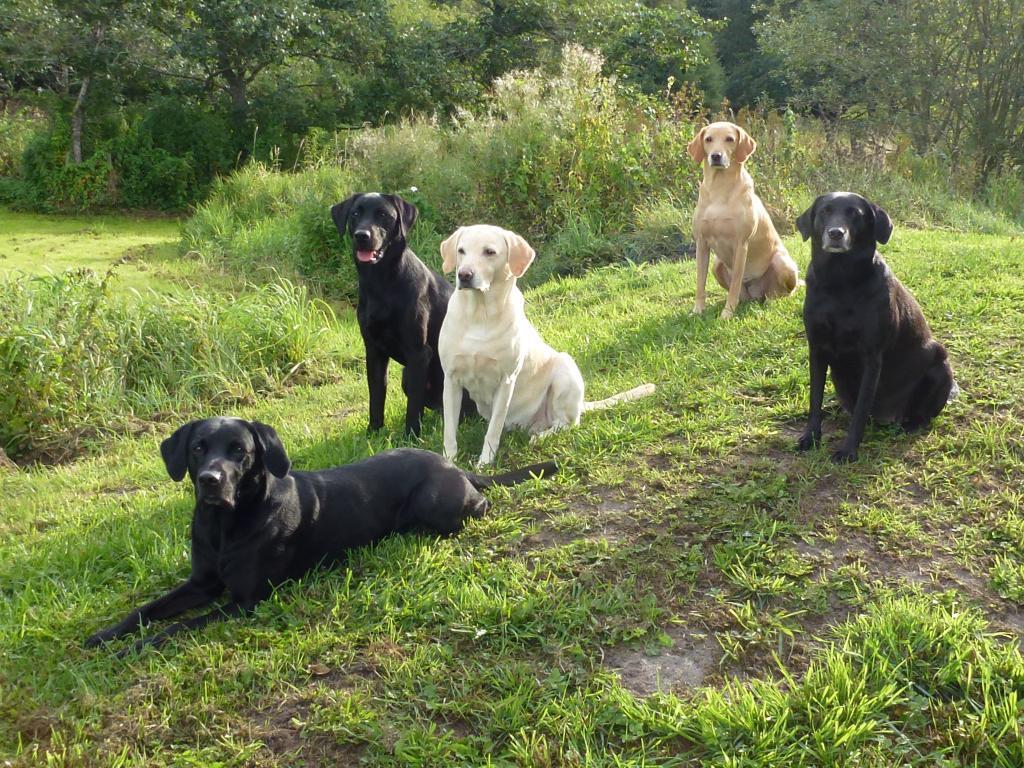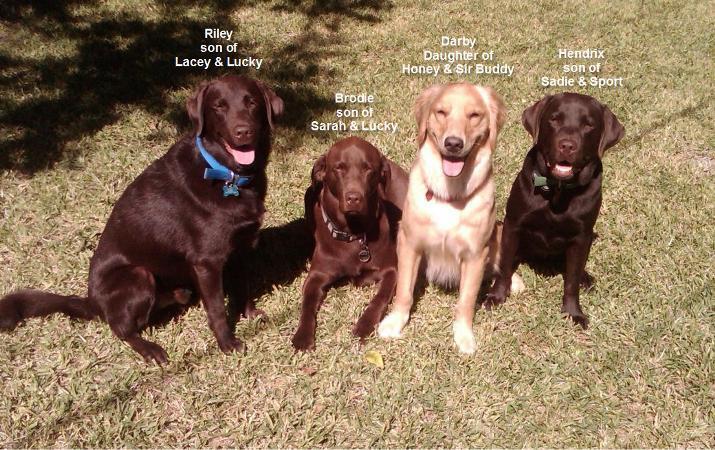The first image is the image on the left, the second image is the image on the right. For the images shown, is this caption "There's no more than three dogs in the right image." true? Answer yes or no. No. The first image is the image on the left, the second image is the image on the right. Assess this claim about the two images: "An image shows dogs in a wet area and includes one black dog with at least six """"blond"""" ones.". Correct or not? Answer yes or no. No. 